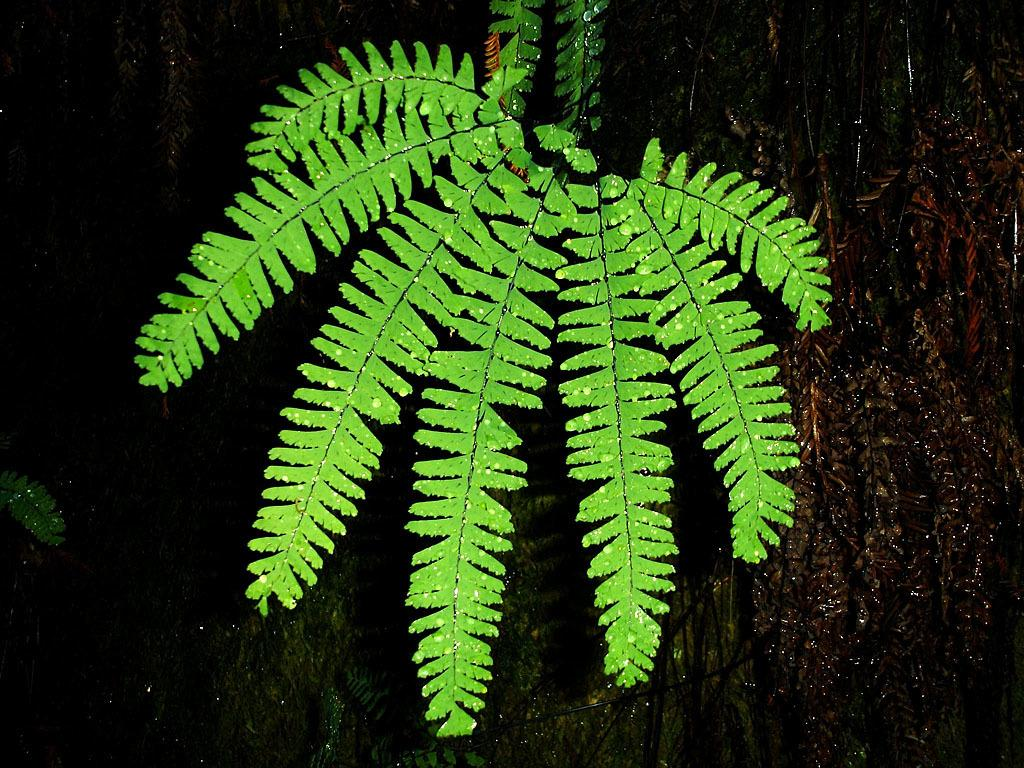What type of vegetation can be seen in the image? There are leaves and trees in the image. What is the color of the background in the image? The background of the image is dark. Can you see a giraffe nesting in the trees in the image? There is no giraffe or nest present in the image; it features leaves and trees against a dark background. 